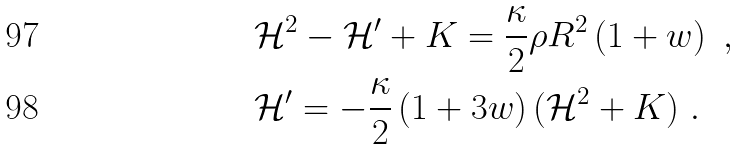Convert formula to latex. <formula><loc_0><loc_0><loc_500><loc_500>& \mathcal { H } ^ { 2 } - \mathcal { H } ^ { \prime } + K = { \frac { \kappa } { 2 } } \rho R ^ { 2 } \left ( 1 + w \right ) \ , \\ & \mathcal { H } ^ { \prime } = - { \frac { \kappa } { 2 } } \left ( 1 + 3 w \right ) ( \mathcal { H } ^ { 2 } + K ) \ .</formula> 